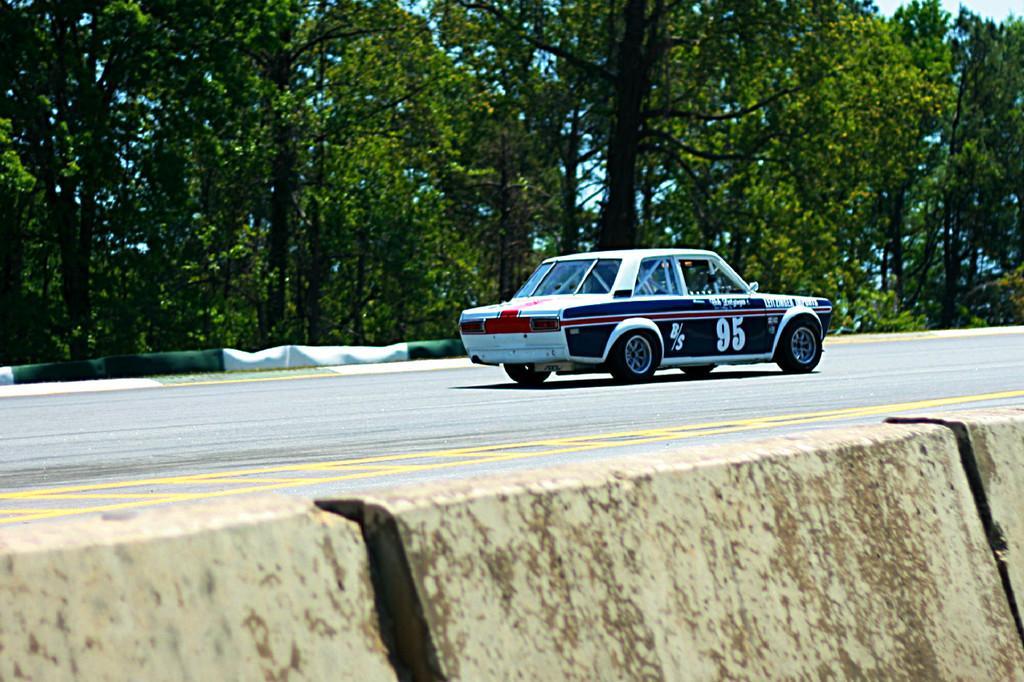Could you give a brief overview of what you see in this image? In this image I can see the divider and there is a vehicle on the road. In the background I can see many trees and the sky. 